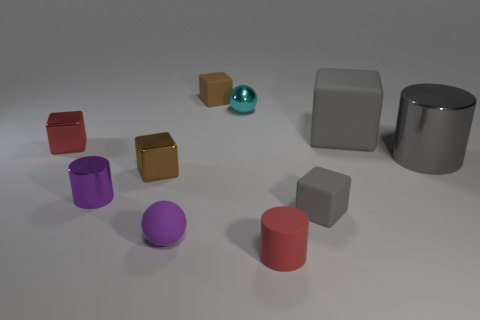There is a brown cube that is made of the same material as the cyan thing; what size is it?
Keep it short and to the point. Small. There is a cylinder that is behind the metal block that is in front of the big gray shiny thing; what color is it?
Your answer should be compact. Gray. Is the shape of the big gray metal object the same as the tiny purple object that is behind the tiny rubber sphere?
Offer a terse response. Yes. What number of purple cylinders have the same size as the red matte cylinder?
Provide a short and direct response. 1. What is the material of the tiny red object that is the same shape as the small brown matte thing?
Your answer should be compact. Metal. Is the color of the shiny object that is behind the tiny red metallic block the same as the cube on the right side of the small gray matte thing?
Offer a very short reply. No. There is a tiny red object on the left side of the tiny cyan metallic object; what shape is it?
Ensure brevity in your answer.  Cube. What is the color of the small metal cylinder?
Keep it short and to the point. Purple. What is the shape of the gray thing that is made of the same material as the purple cylinder?
Your answer should be compact. Cylinder. There is a brown block behind the red block; is it the same size as the gray metal object?
Offer a terse response. No. 